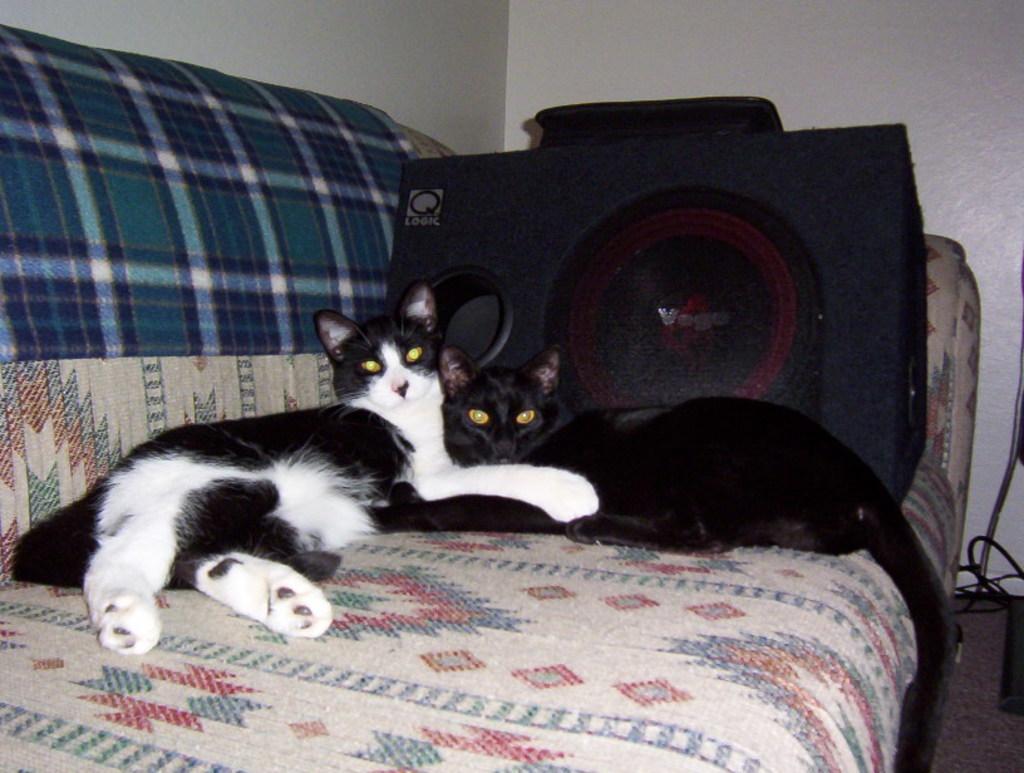In one or two sentences, can you explain what this image depicts? In the picture I can see two cats lying on the sofa. In the background I can see white color wall and some other objects. 